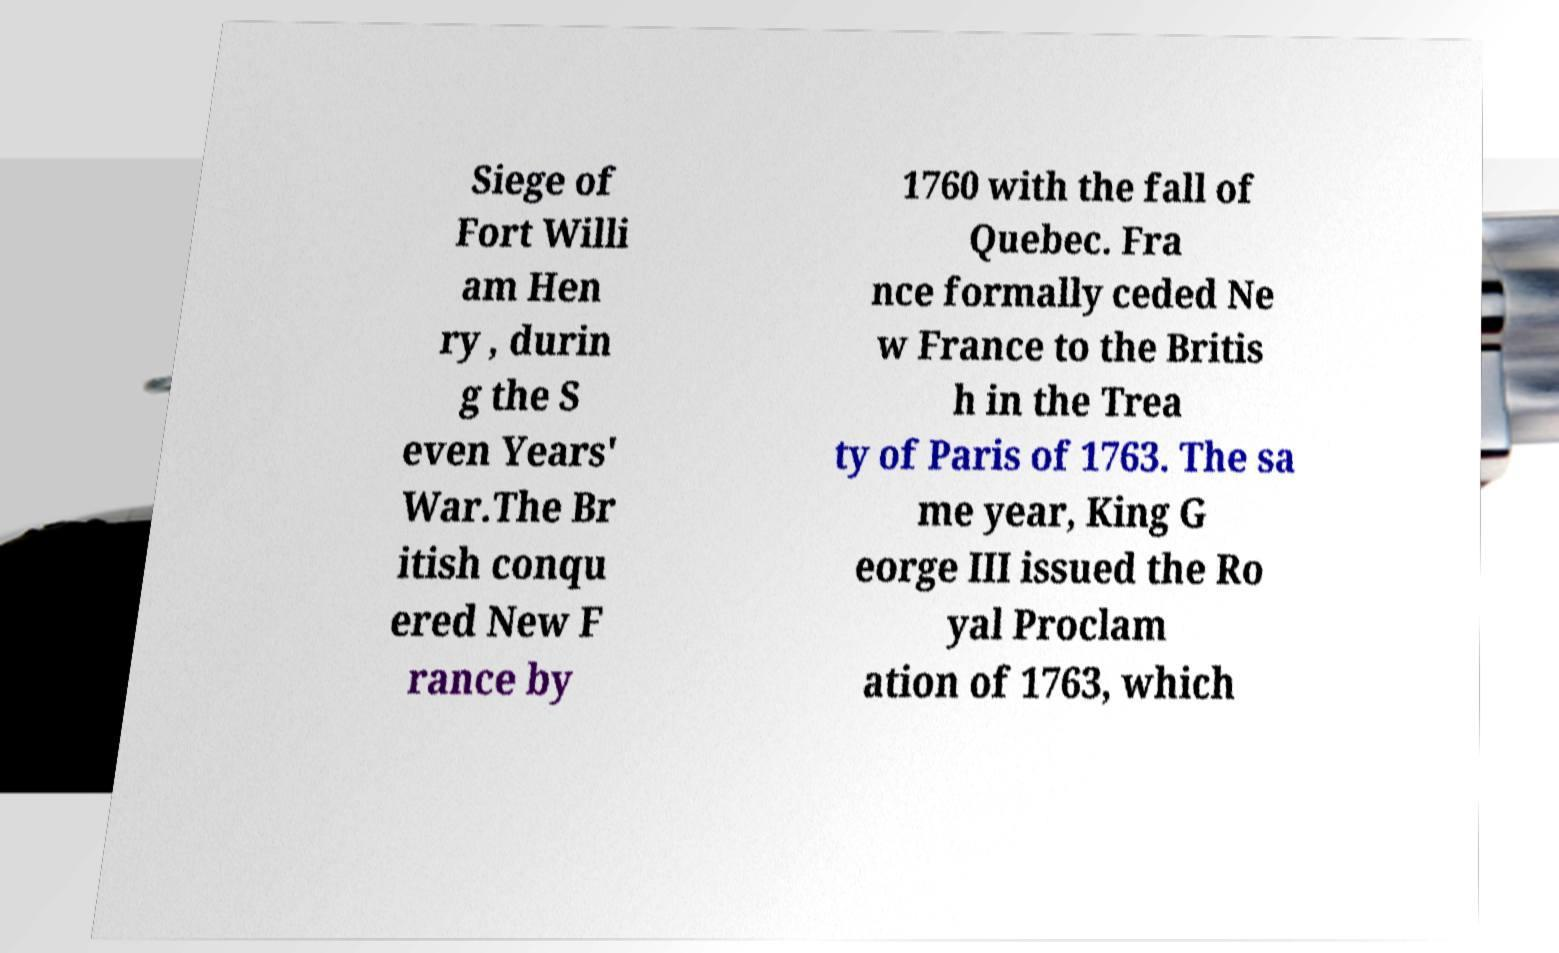Can you read and provide the text displayed in the image?This photo seems to have some interesting text. Can you extract and type it out for me? Siege of Fort Willi am Hen ry , durin g the S even Years' War.The Br itish conqu ered New F rance by 1760 with the fall of Quebec. Fra nce formally ceded Ne w France to the Britis h in the Trea ty of Paris of 1763. The sa me year, King G eorge III issued the Ro yal Proclam ation of 1763, which 